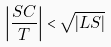Convert formula to latex. <formula><loc_0><loc_0><loc_500><loc_500>\left | \frac { S C } { T } \right | < \sqrt { \left | L S \right | }</formula> 